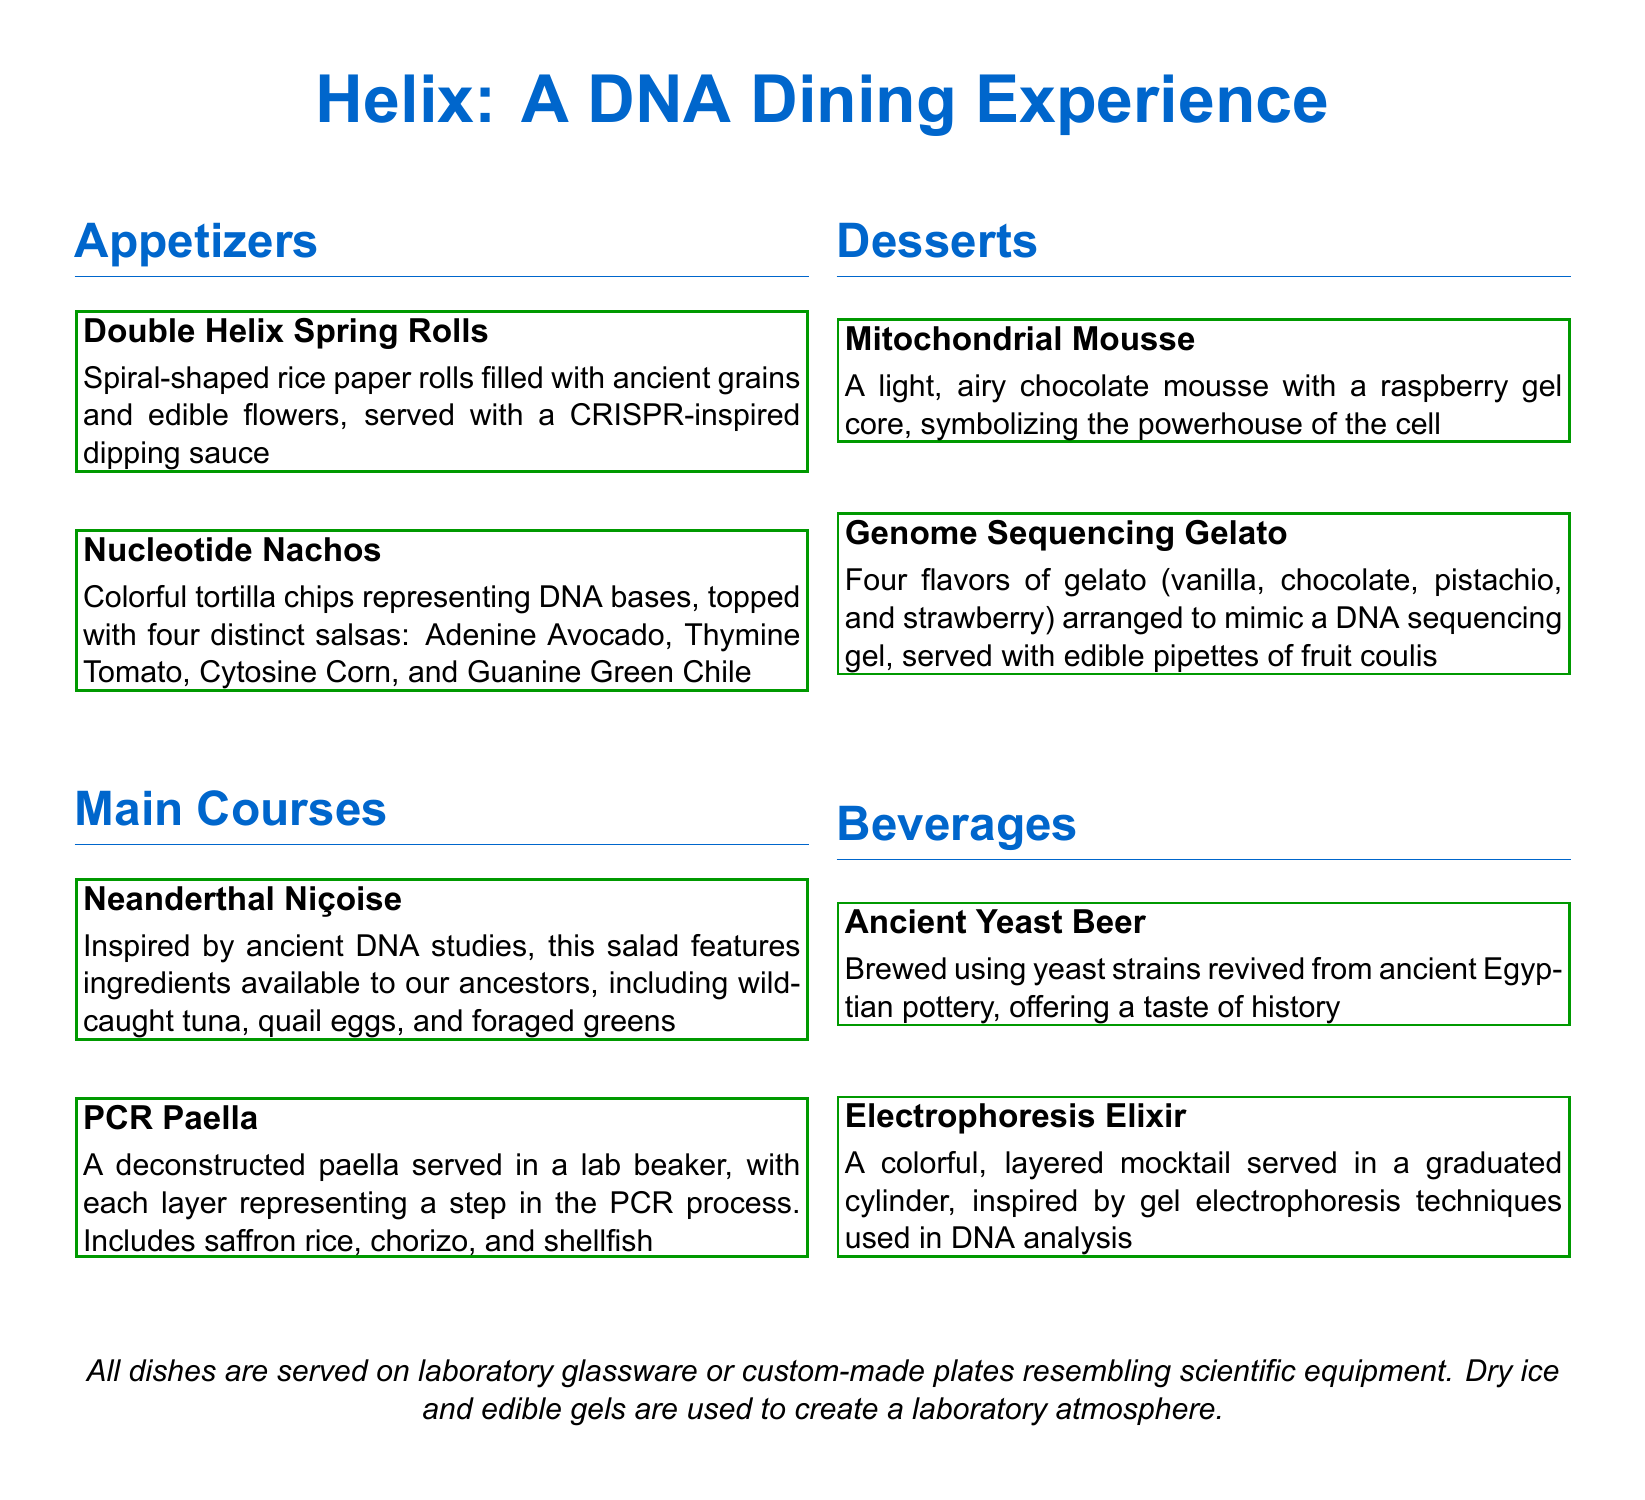What is the name of the restaurant? The name of the restaurant is given in the document's title.
Answer: Helix: A DNA Dining Experience How many appetizers are listed? The document lists three sections, including appetizers, and mentions two appetizers under that section.
Answer: 2 What dish is inspired by ancient DNA studies? The dish inspired by ancient DNA studies is identified in the main courses section.
Answer: Neanderthal Niçoise What unique serving style is used for desserts? The document specifies a particular type of glassware used for serving, which is typical for this restaurant.
Answer: Laboratory glassware Which drink is brewed using ancient yeast strains? The drink brewed using ancient yeast strains is detailed in the beverages section.
Answer: Ancient Yeast Beer What flavor is the core of the Mitochondrial Mousse? The mousse has a specific filling or core described in the document.
Answer: Raspberry gel How are the gelato flavors arranged? The document describes a specific arrangement style for the gelato that mimics a scientific technique.
Answer: DNA sequencing gel What visual effect is created with dry ice? The use of dry ice is mentioned to enhance the dining experience's atmosphere.
Answer: Laboratory atmosphere Which dish is served in a lab beaker? The dish that is served in this unique way is specified in the main courses section.
Answer: PCR Paella 